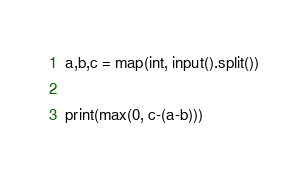Convert code to text. <code><loc_0><loc_0><loc_500><loc_500><_Python_>a,b,c = map(int, input().split())

print(max(0, c-(a-b)))</code> 